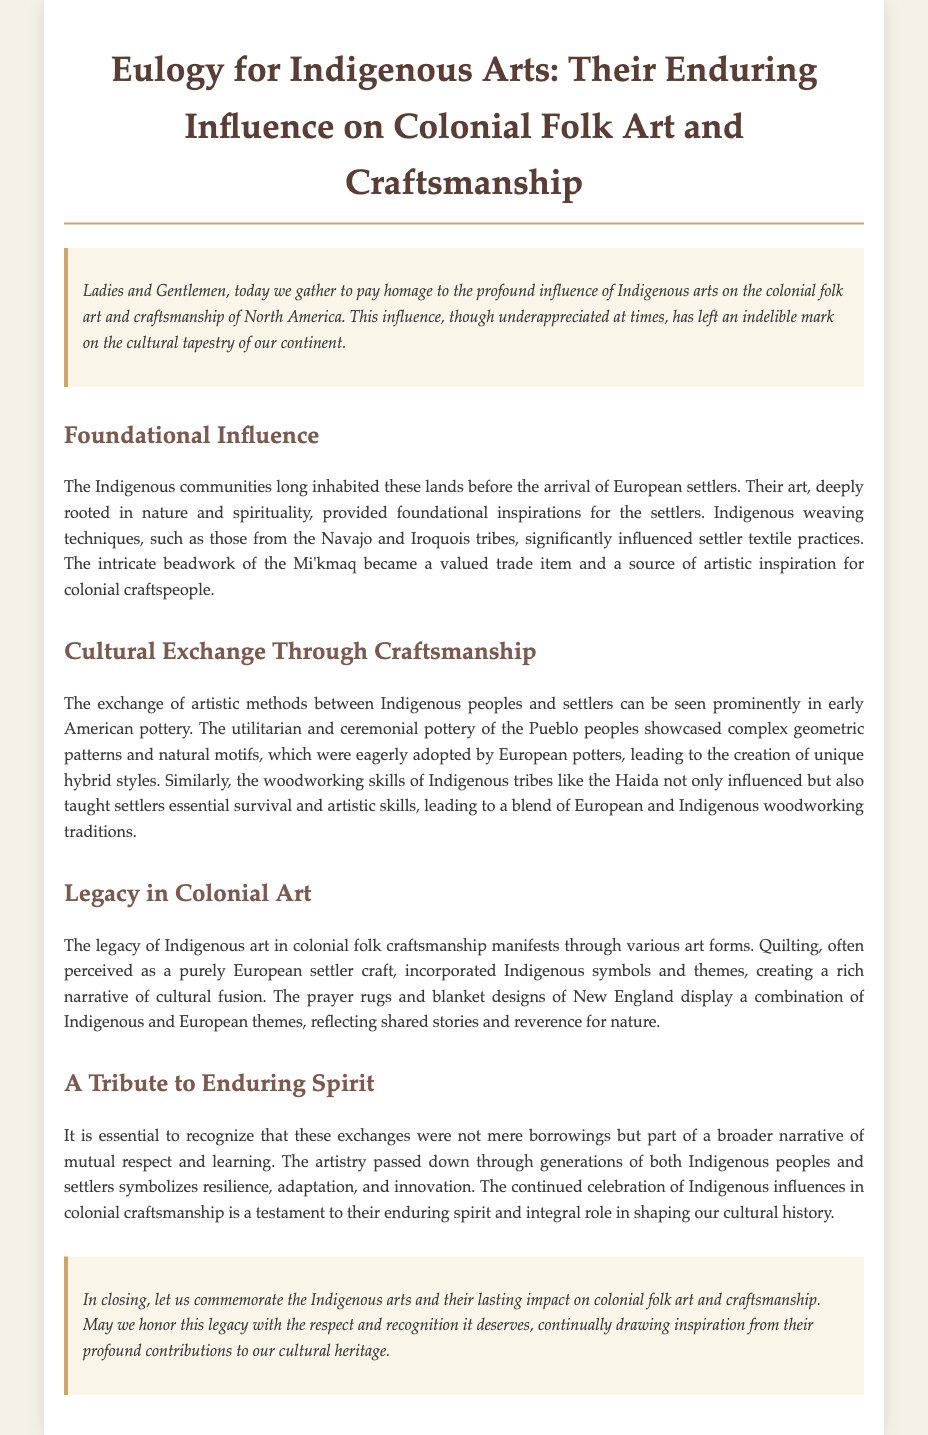What is the main theme of the eulogy? The eulogy focuses on the influence of Indigenous arts on colonial folk art and craftsmanship in North America.
Answer: Indigenous arts influence on colonial folk art Who are mentioned as the Indigenous tribes that contributed to weaving techniques? The document specifically mentions the Navajo and Iroquois tribes for their weaving techniques.
Answer: Navajo and Iroquois What type of pottery is highlighted as influencing early American pottery? The document discusses the ceremonial pottery of the Pueblo peoples and its impact on European potters.
Answer: Pueblo pottery Which Indigenous tribe's woodworking skills are noted in influencing settlers? The Haida tribe's woodworking skills are recognized for influencing settlers' carpentry practices.
Answer: Haida What artistic practice is said to incorporate Indigenous symbols and themes? The document states that quilting incorporates Indigenous symbols and themes, reflecting cultural fusion.
Answer: Quilting How does the eulogy suggest the exchanges between Indigenous peoples and settlers were viewed? The eulogy describes these exchanges as part of a broader narrative of mutual respect and learning.
Answer: Mutual respect and learning What does the eulogy encourage regarding the legacy of Indigenous arts? The eulogy encourages honoring the legacy with respect and recognition for its contributions to cultural heritage.
Answer: Respect and recognition In what region are the prayer rugs and blanket designs mentioned? The region highlighted for these designs is New England, showcasing a blend of themes.
Answer: New England 